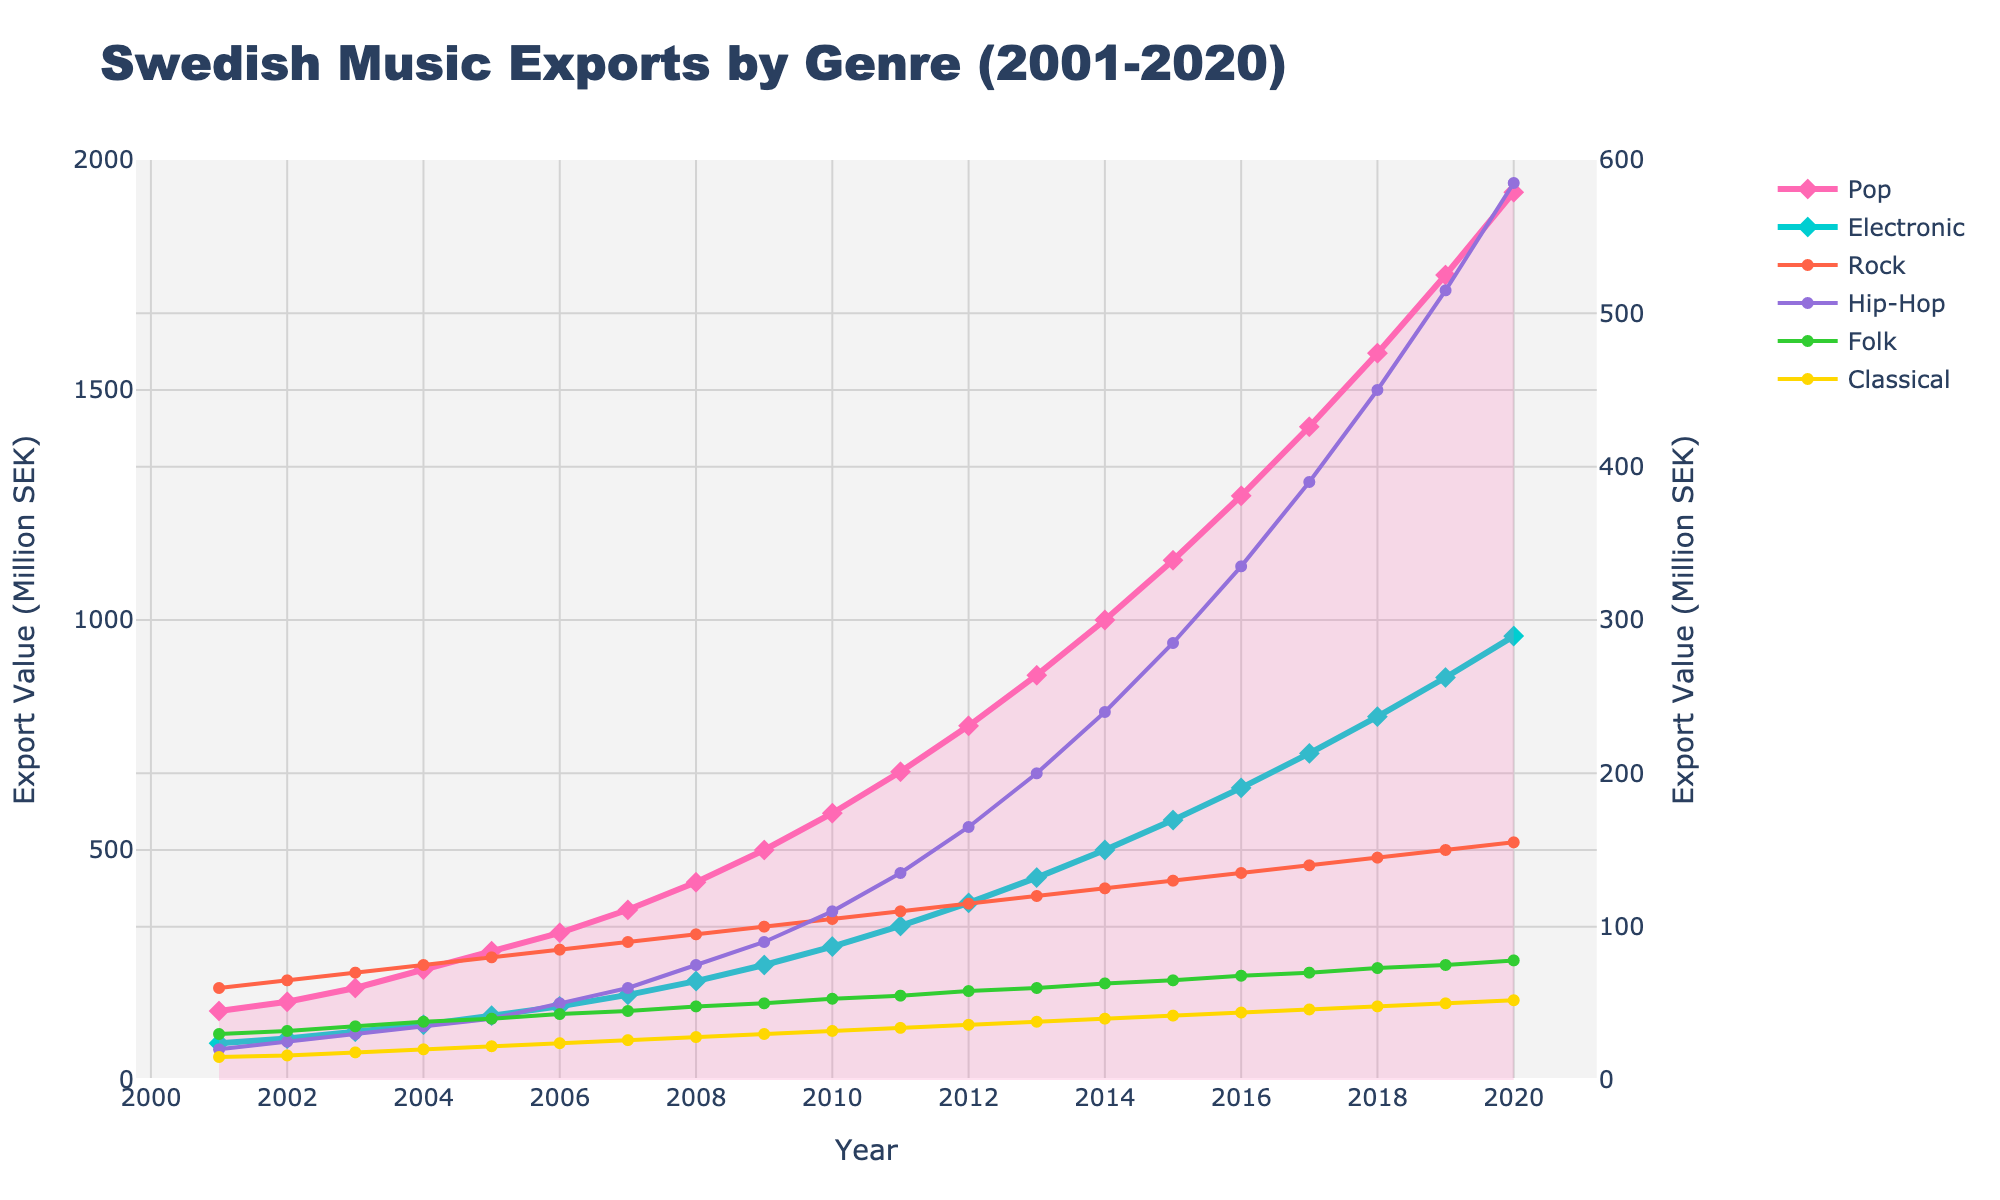What's the peak export value for the Rock genre and in which year did it occur? Identify the highest point on the line representing the Rock genre, and read off the corresponding year. The highest value for Rock is 155 million SEK in 2020.
Answer: 155 million SEK in 2020 How much did the export value for the Hip-Hop genre change between 2010 and 2015? Look at the values for the Hip-Hop genre in 2010 and 2015, then subtract the earlier value from the later one. The values are 110 million SEK in 2010 and 285 million SEK in 2015. The change is 285 - 110 = 175 million SEK.
Answer: 175 million SEK Which genre had the smallest increase in export value from 2001 to 2020? Calculate the increase for each genre by subtracting the 2001 value from the 2020 value. Compare the increases for all genres: Pop (1780), Electronic (885), Rock (95), Hip-Hop (565), Folk (48), Classical (37). The smallest increase is for Classical.
Answer: Classical Between 2005 and 2010, which genre saw the largest relative growth in export value? Calculate the relative growth for each genre by finding the export values for 2005 and 2010, and then using the formula (value in 2010 - value in 2005) / value in 2005. Compare these values. Pop (300%), Electronic (107%), Rock (31.25%), Hip-Hop (175%), Folk (32.5%), Classical (45.45%). The largest relative growth is for Pop.
Answer: Pop What is the average export value for the Folk genre over the entire period? Sum the export values of the Folk genre for all years and divide by the number of years (20). The values sum to 1065, so the average is 1065 / 20 = 53.25 million SEK.
Answer: 53.25 million SEK In which year did the Electronic genre surpass 500 million SEK in export value? Identify the point on the line representing the Electronic genre where the value first exceeds 500 million SEK. This occurs in 2014 when the value reaches 500 million SEK.
Answer: 2014 By how much did the export value for Pop exceed that of Electronic in 2016? Find the export values for Pop and Electronic in 2016 and take the difference. Pop is at 1270 million SEK and Electronic is at 635 million SEK. The difference is 1270 - 635 = 635 million SEK.
Answer: 635 million SEK Which genre appears to have the widest shaded area under its curve? Visually inspect the shaded areas and note the genre associated with the widest area. The Pop genre has the widest shaded area under its curve compared to others.
Answer: Pop What was the combined export value for Pop and Hip-Hop in 2010? Add the export values for Pop and Hip-Hop in 2010. Pop is 580 million SEK and Hip-Hop is 110 million SEK. The combined value is 580 + 110 = 690 million SEK.
Answer: 690 million SEK What trend is observed in the Electronic genre's export value between 2007 and 2014? Observe the general direction and shape of the line representing the Electronic genre between these years. The Electronic genre shows a steadily increasing trend from 2007 to 2014, moving from 185 million SEK to 500 million SEK.
Answer: Steadily increasing 